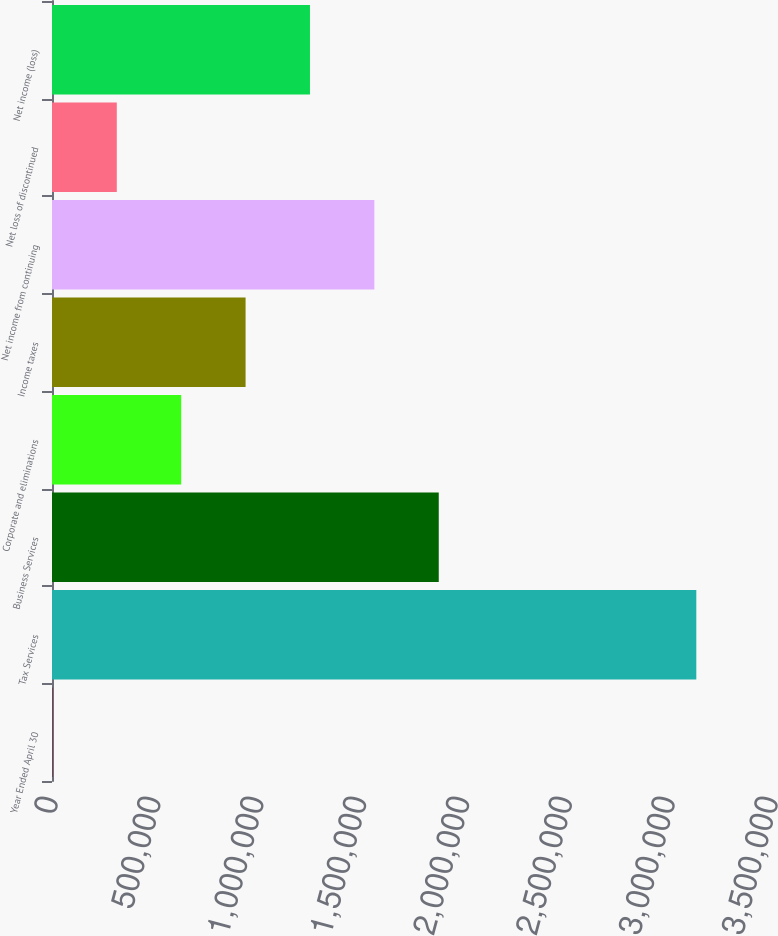<chart> <loc_0><loc_0><loc_500><loc_500><bar_chart><fcel>Year Ended April 30<fcel>Tax Services<fcel>Business Services<fcel>Corporate and eliminations<fcel>Income taxes<fcel>Net income from continuing<fcel>Net loss of discontinued<fcel>Net income (loss)<nl><fcel>2009<fcel>3.13208e+06<fcel>1.88005e+06<fcel>628023<fcel>941029<fcel>1.56704e+06<fcel>315016<fcel>1.25404e+06<nl></chart> 